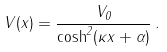Convert formula to latex. <formula><loc_0><loc_0><loc_500><loc_500>V ( x ) = \frac { V _ { 0 } } { \cosh ^ { 2 } ( \kappa x + \alpha ) } \, .</formula> 